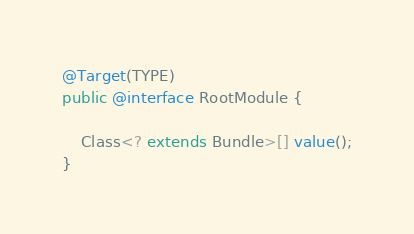<code> <loc_0><loc_0><loc_500><loc_500><_Java_>@Target(TYPE)
public @interface RootModule {

	Class<? extends Bundle>[] value();
}
</code> 